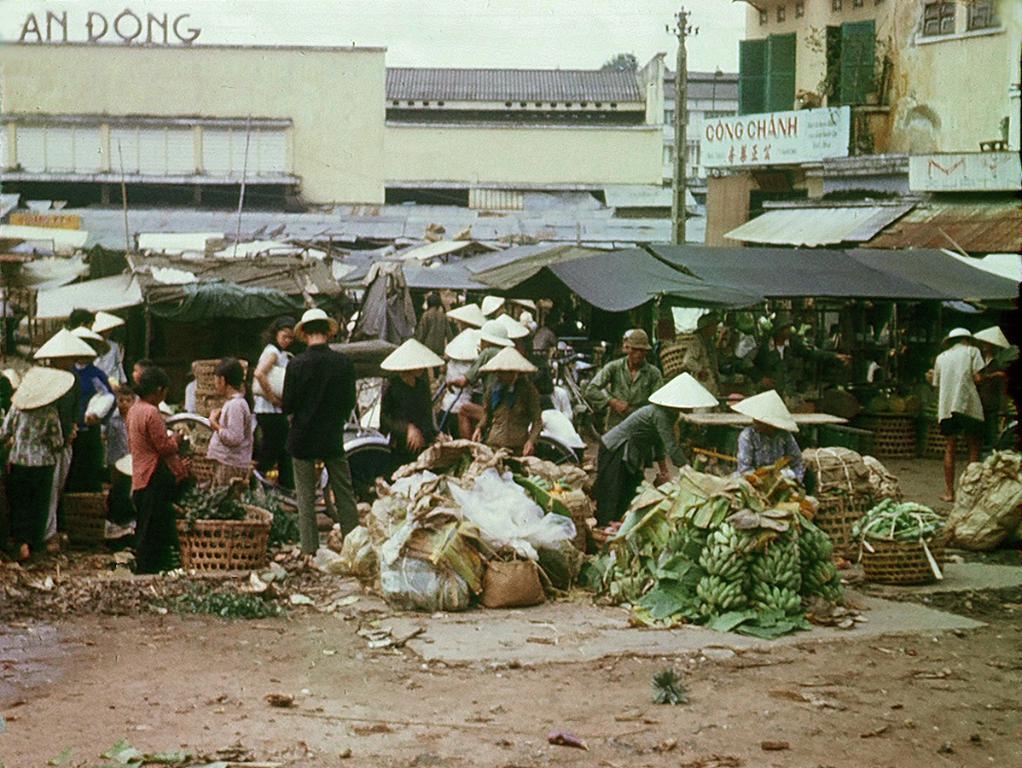Describe this image in one or two sentences. In the picture I can see buildings, people standing on the ground, bananas, baskets, bags, stalls, a pole, vegetables and some other objects. These people are wearing hats. In the background I can see the sky. 